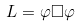<formula> <loc_0><loc_0><loc_500><loc_500>L = \varphi \square \varphi</formula> 